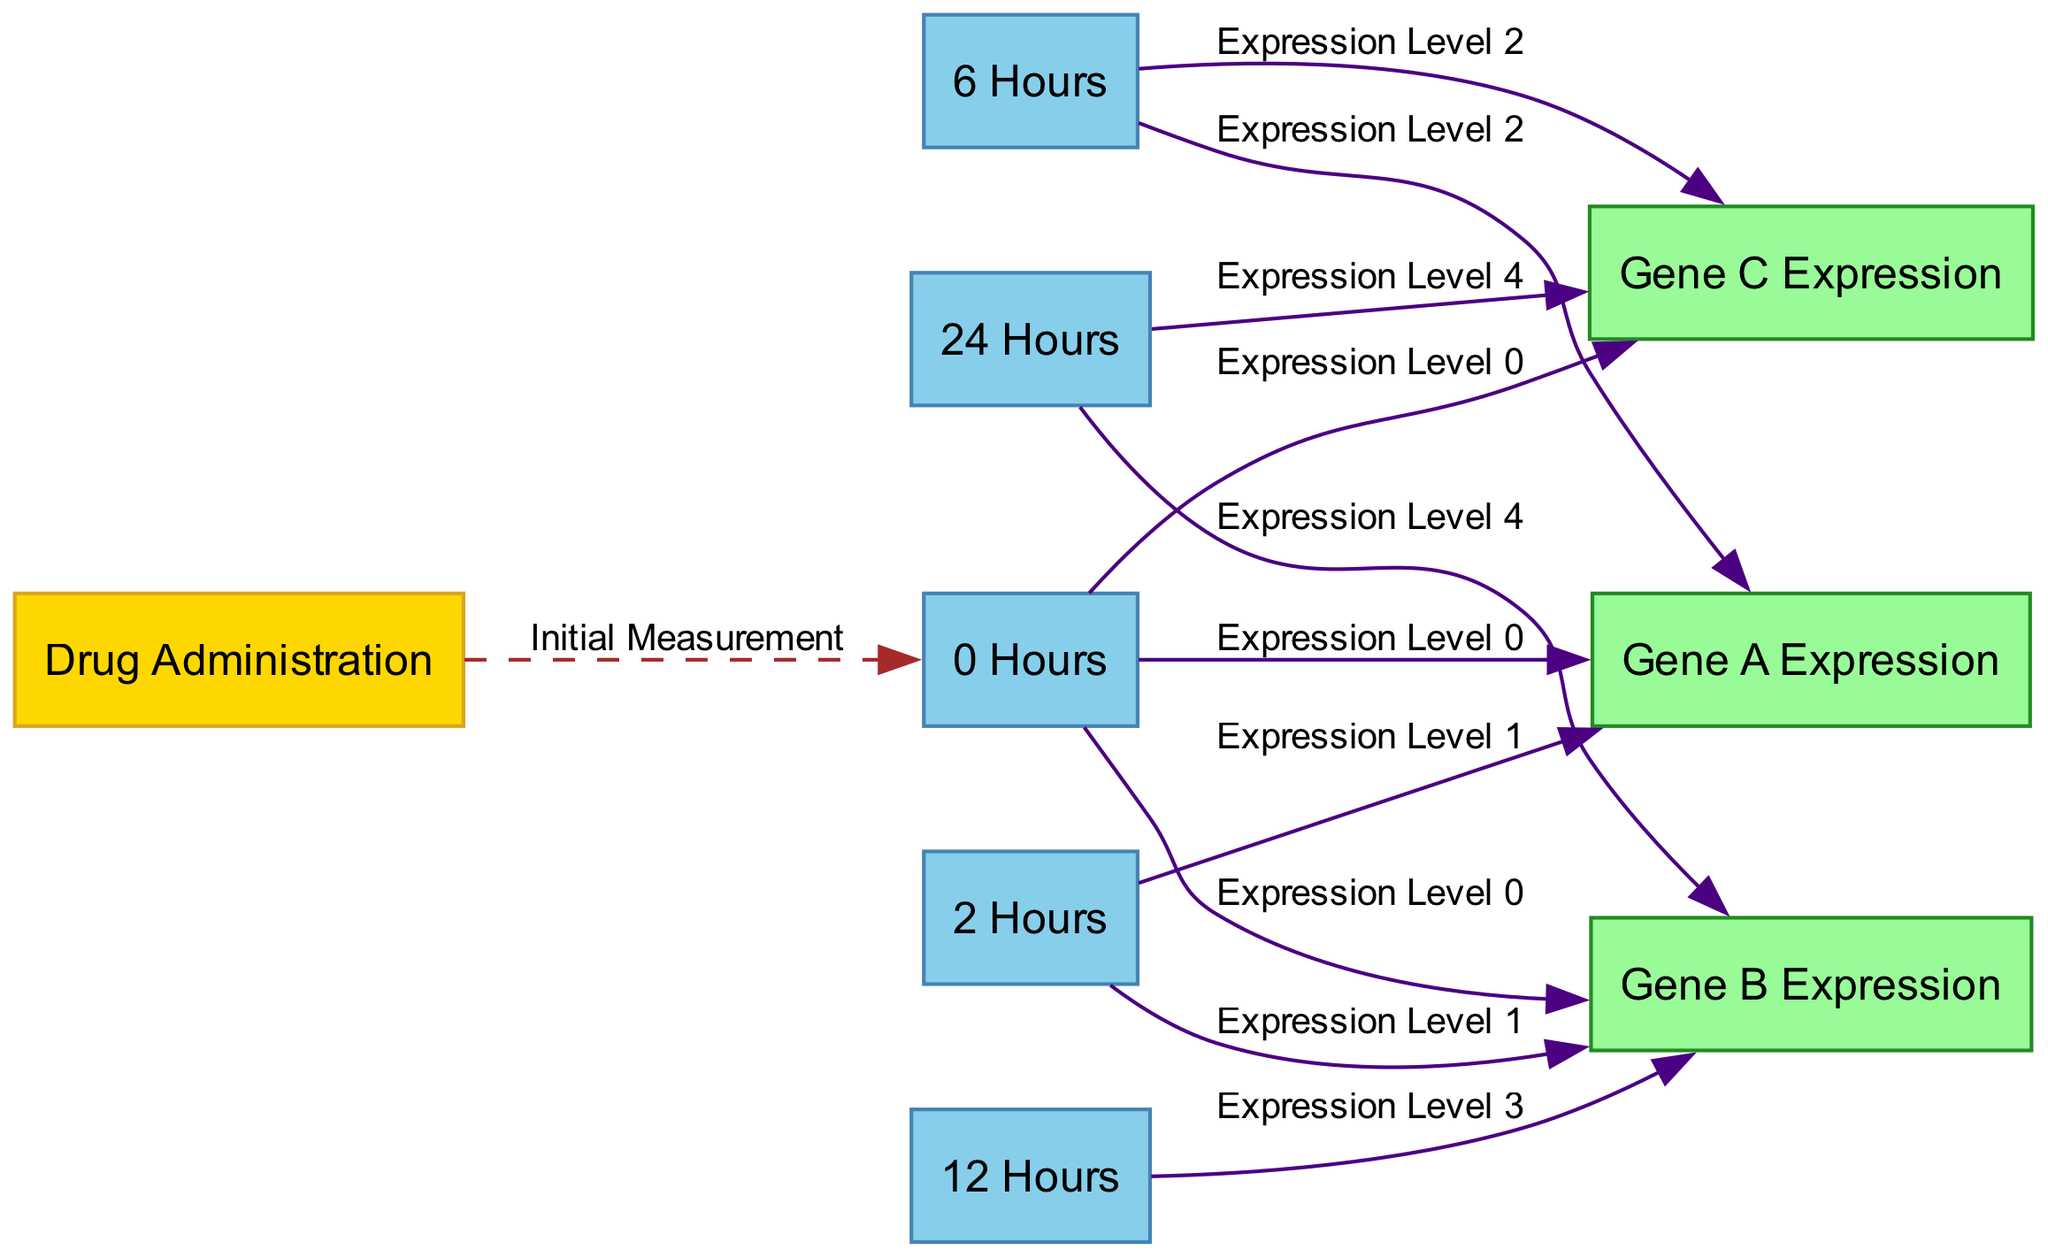What is the label of the initial measurement node? In the diagram, the initial measurement node is connected to the "Drug Administration" node and represents time point 0, the label given is "Initial Measurement."
Answer: Initial Measurement How many time points are represented in the diagram? The diagram has five time points labeled "0 Hours," "2 Hours," "6 Hours," "12 Hours," and "24 Hours," which totals to five time points.
Answer: 5 Which gene shows expression data at 12 hours? From the diagram, we can see that only "Gene B Expression" has a data point at 12 hours, as indicated by the edge from time point 3 to gene B.
Answer: Gene B Expression What is the expression level of Gene A at 2 hours? By examining the connections in the diagram, Gene A has a corresponding edge from the "2 Hours" node to "Gene A Expression," indicating its expression level at this time point is noted as "Expression Level 1."
Answer: Expression Level 1 Which gene has expression levels recorded at both 0 and 24 hours? Looking closely at the data points in the diagram, "Gene C Expression" has edges from both the "0 Hours" and "24 Hours," making it the gene with recorded expression levels at these time points.
Answer: Gene C Expression What type of relationship connects drug administration to time point 0? The relationship between "Drug Administration" and "0 Hours" is classified as a "time_transition," indicating a temporal relationship that illustrates events occurring over time following drug administration.
Answer: time_transition Which gene expressions do not have measurements after 6 hours? Analyzing the edges, only "Gene A Expression" and "Gene C Expression" have measurements recorded, while "Gene B Expression" continues to have data points up to 24 hours. Thus, Gene A and Gene C do not have measurements beyond 6 hours.
Answer: Gene A Expression, Gene C Expression At which time point does Gene B first show an expression level increase? By reviewing the time points, Gene B first shows an increase at "2 Hours" when it transitions from "Expression Level 0" at home to "Expression Level 1".
Answer: 2 Hours 